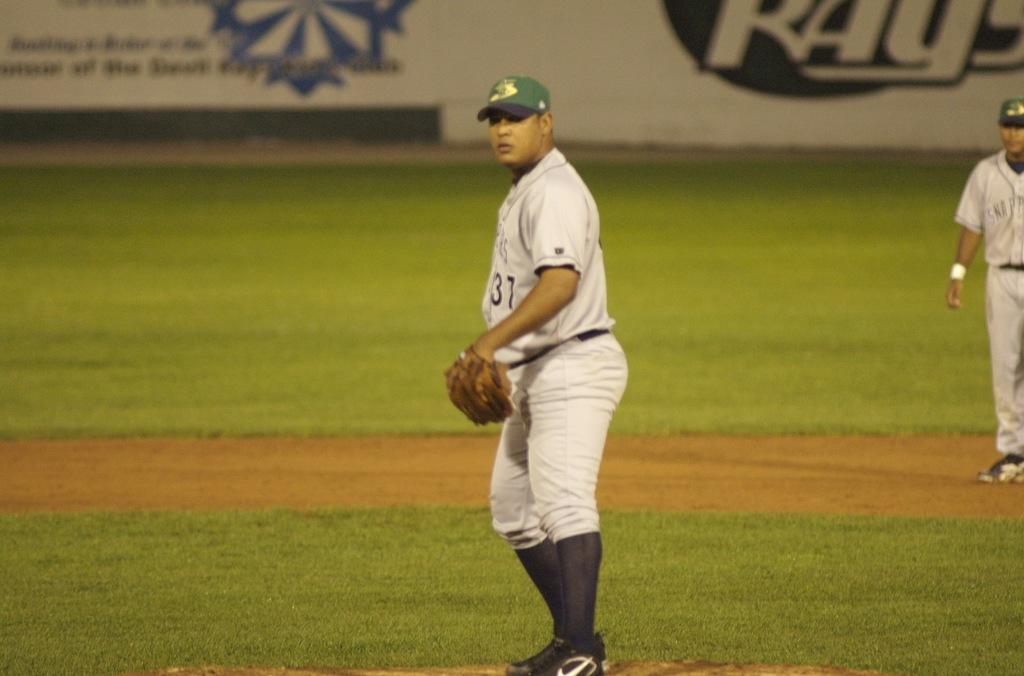What number is this player?
Give a very brief answer. 31. What team does this man play for?
Offer a very short reply. Unanswerable. 